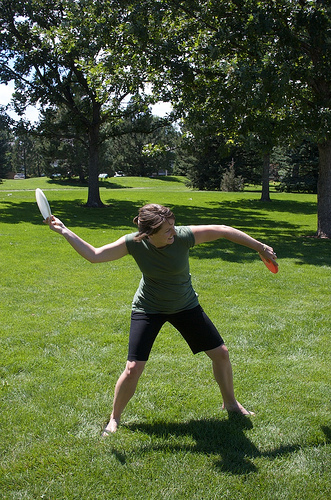<image>What kind of shoes is the woman wearing? I don't know what kind of shoes the woman is wearing. It could be sandals, flip flops, or even tennis shoes. What kind of shoes is the woman wearing? I am not sure what kind of shoes the woman is wearing. It can be flip flops, sandals or tennis shoes. 